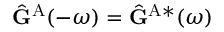Convert formula to latex. <formula><loc_0><loc_0><loc_500><loc_500>\hat { G } ^ { A } ( - \omega ) = \hat { G } ^ { A * } ( \omega )</formula> 